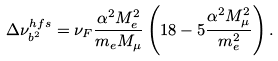Convert formula to latex. <formula><loc_0><loc_0><loc_500><loc_500>\Delta \nu ^ { h f s } _ { b ^ { 2 } } = \nu _ { F } \frac { \alpha ^ { 2 } M _ { e } ^ { 2 } } { m _ { e } M _ { \mu } } \left ( 1 8 - 5 \frac { \alpha ^ { 2 } M _ { \mu } ^ { 2 } } { m _ { e } ^ { 2 } } \right ) .</formula> 